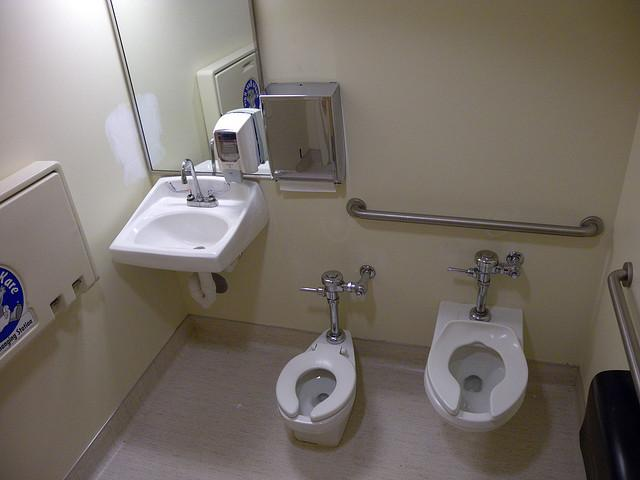How many items appear to be made of porcelain? Please explain your reasoning. three. The sink and both of the toilets are made out of porcelain. 